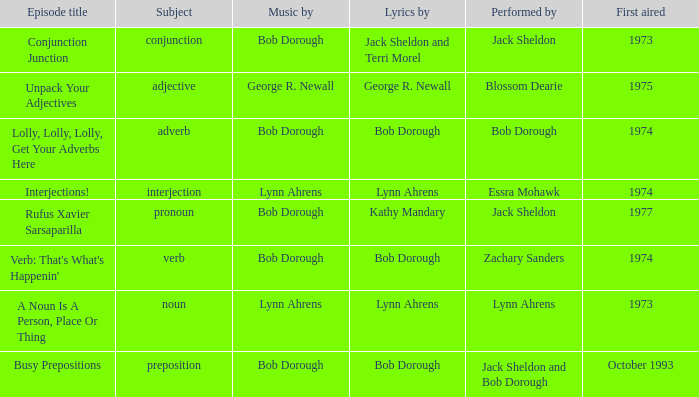In case of interjection being the subject, who is responsible for the lyrics? Lynn Ahrens. 